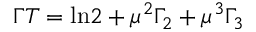<formula> <loc_0><loc_0><loc_500><loc_500>\Gamma T = \ln \, 2 + \mu ^ { 2 } \Gamma _ { 2 } + \mu ^ { 3 } \Gamma _ { 3 }</formula> 